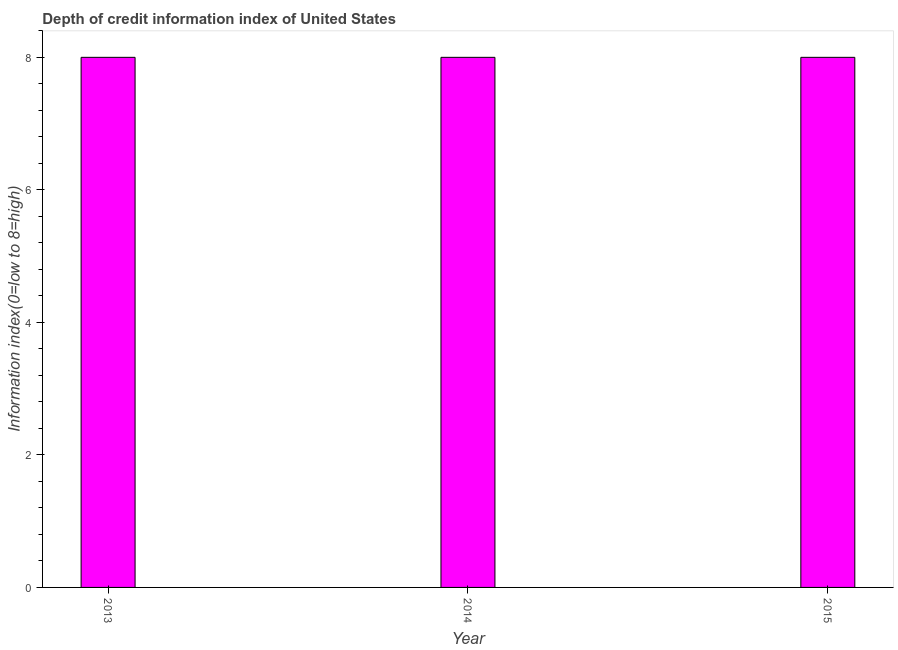What is the title of the graph?
Offer a very short reply. Depth of credit information index of United States. What is the label or title of the Y-axis?
Your answer should be compact. Information index(0=low to 8=high). Across all years, what is the minimum depth of credit information index?
Provide a succinct answer. 8. In which year was the depth of credit information index maximum?
Offer a very short reply. 2013. In which year was the depth of credit information index minimum?
Provide a succinct answer. 2013. What is the sum of the depth of credit information index?
Keep it short and to the point. 24. What is the difference between the depth of credit information index in 2013 and 2014?
Keep it short and to the point. 0. What is the average depth of credit information index per year?
Offer a very short reply. 8. In how many years, is the depth of credit information index greater than 6.4 ?
Ensure brevity in your answer.  3. Do a majority of the years between 2015 and 2013 (inclusive) have depth of credit information index greater than 6.4 ?
Offer a very short reply. Yes. Is the depth of credit information index in 2013 less than that in 2015?
Your answer should be very brief. No. Is the difference between the depth of credit information index in 2013 and 2014 greater than the difference between any two years?
Your answer should be compact. Yes. Is the sum of the depth of credit information index in 2013 and 2015 greater than the maximum depth of credit information index across all years?
Provide a short and direct response. Yes. What is the difference between the highest and the lowest depth of credit information index?
Offer a very short reply. 0. In how many years, is the depth of credit information index greater than the average depth of credit information index taken over all years?
Your response must be concise. 0. How many bars are there?
Make the answer very short. 3. How many years are there in the graph?
Provide a short and direct response. 3. What is the difference between two consecutive major ticks on the Y-axis?
Ensure brevity in your answer.  2. 